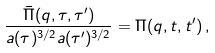<formula> <loc_0><loc_0><loc_500><loc_500>\frac { \bar { \Pi } ( { q } , \tau , \tau ^ { \prime } ) } { a ( \tau ) ^ { 3 / 2 } a ( \tau ^ { \prime } ) ^ { 3 / 2 } } = \Pi ( { q } , t , t ^ { \prime } ) \, ,</formula> 